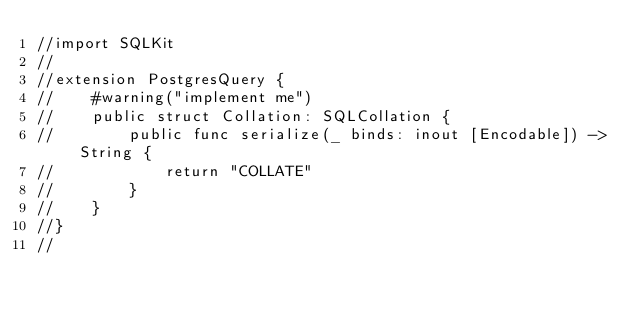<code> <loc_0><loc_0><loc_500><loc_500><_Swift_>//import SQLKit
//
//extension PostgresQuery {
//    #warning("implement me")
//    public struct Collation: SQLCollation {
//        public func serialize(_ binds: inout [Encodable]) -> String {
//            return "COLLATE"
//        }
//    }
//}
//
</code> 